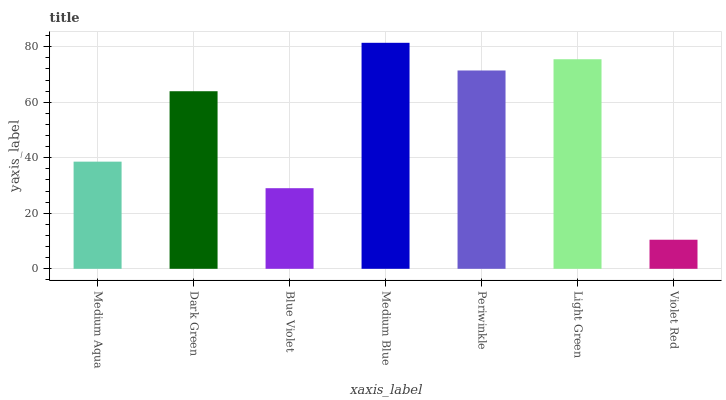Is Dark Green the minimum?
Answer yes or no. No. Is Dark Green the maximum?
Answer yes or no. No. Is Dark Green greater than Medium Aqua?
Answer yes or no. Yes. Is Medium Aqua less than Dark Green?
Answer yes or no. Yes. Is Medium Aqua greater than Dark Green?
Answer yes or no. No. Is Dark Green less than Medium Aqua?
Answer yes or no. No. Is Dark Green the high median?
Answer yes or no. Yes. Is Dark Green the low median?
Answer yes or no. Yes. Is Medium Aqua the high median?
Answer yes or no. No. Is Violet Red the low median?
Answer yes or no. No. 